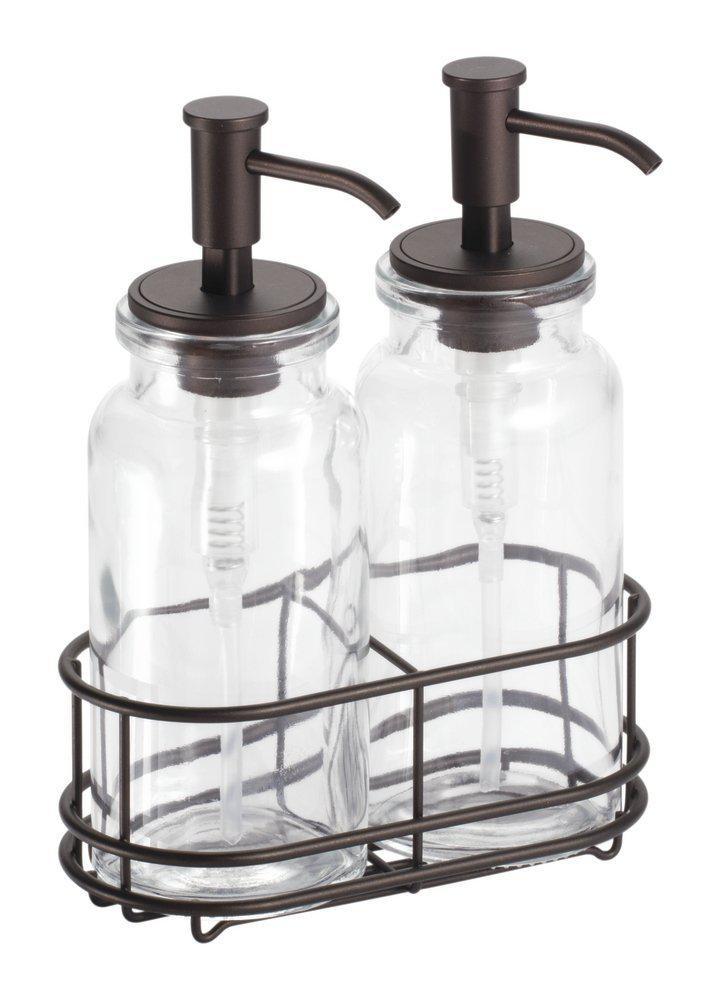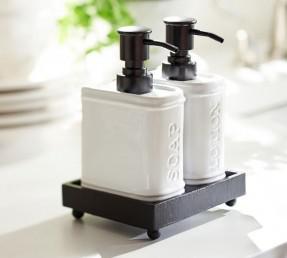The first image is the image on the left, the second image is the image on the right. Assess this claim about the two images: "There are exactly three liquid soap dispenser pumps.". Correct or not? Answer yes or no. No. The first image is the image on the left, the second image is the image on the right. Analyze the images presented: Is the assertion "None of the soap dispensers have stainless steel tops and at least two of the dispensers are made of clear glass." valid? Answer yes or no. Yes. 